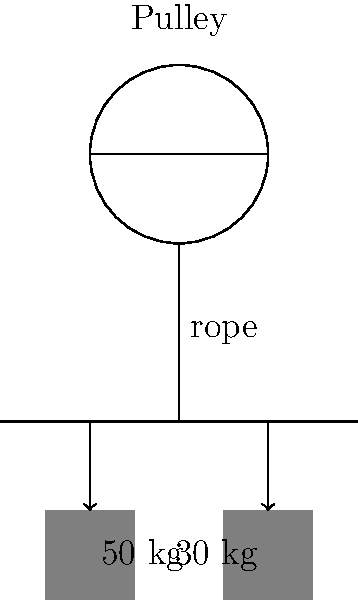As a tour guide in Keele, you often explain local industrial history. A simple pulley system at a nearby museum demonstrates early mining techniques. The system has a single fixed pulley with a 50 kg weight on one side and a 30 kg weight on the other. Assuming the system is frictionless, what is its efficiency? To calculate the efficiency of this pulley system, we need to follow these steps:

1. Understand the concept: In an ideal (frictionless) pulley system, the efficiency is 100% as all input work is converted to output work.

2. Analyze the system: 
   - The heavier weight (50 kg) will move downward.
   - The lighter weight (30 kg) will move upward.
   - The net force causing motion is the difference between these weights.

3. Calculate the efficiency:
   - Efficiency = (Output Work / Input Work) × 100%
   - In this case, Output Work = Input Work (as the system is frictionless)
   - Therefore, Efficiency = (Input Work / Input Work) × 100% = 100%

4. Consider real-world implications:
   - In reality, there would be some friction in the pulley and rope, reducing efficiency.
   - However, the question specifies a frictionless system, so we ignore these factors.

5. Conclusion:
   The efficiency of this ideal, frictionless pulley system is 100%.
Answer: 100% 